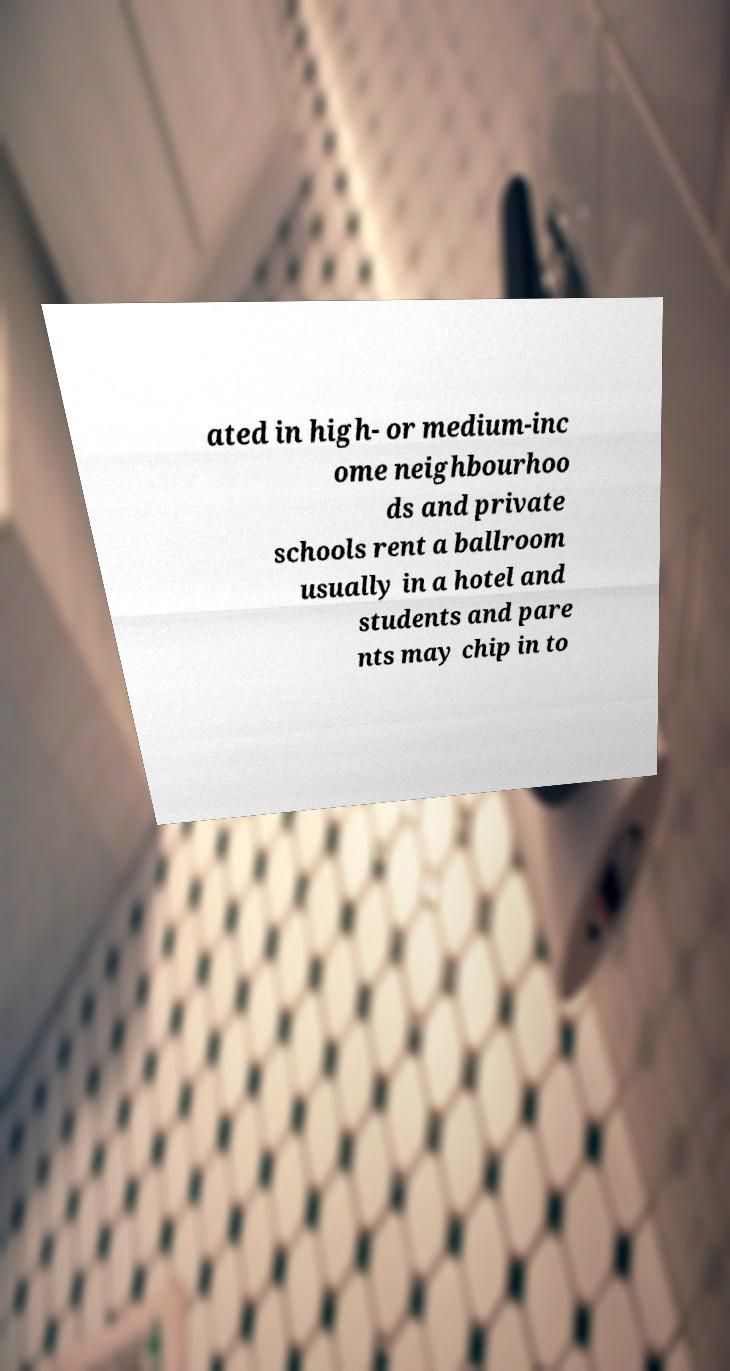Can you accurately transcribe the text from the provided image for me? ated in high- or medium-inc ome neighbourhoo ds and private schools rent a ballroom usually in a hotel and students and pare nts may chip in to 